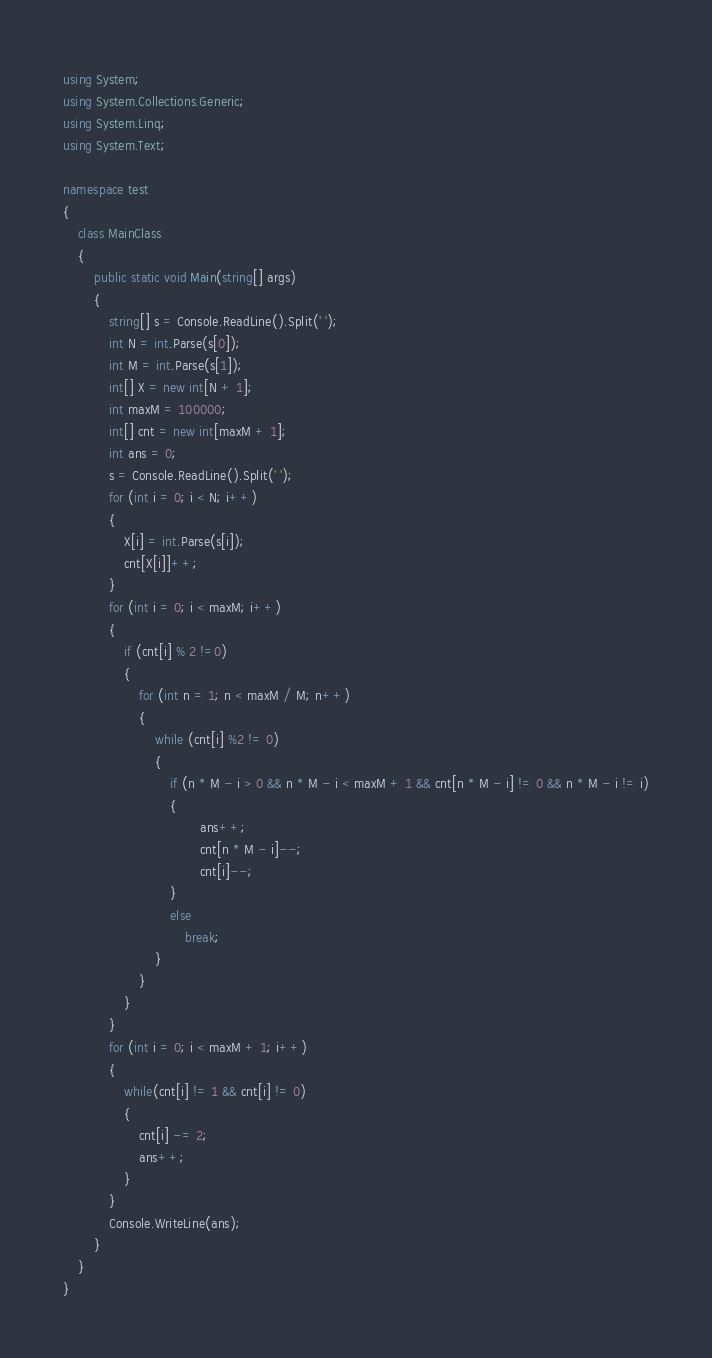Convert code to text. <code><loc_0><loc_0><loc_500><loc_500><_C#_>using System;
using System.Collections.Generic;
using System.Linq;
using System.Text;

namespace test
{
	class MainClass
	{
		public static void Main(string[] args)
		{
			string[] s = Console.ReadLine().Split(' ');
			int N = int.Parse(s[0]);
			int M = int.Parse(s[1]);
			int[] X = new int[N + 1];
			int maxM = 100000;
			int[] cnt = new int[maxM + 1];
			int ans = 0;
			s = Console.ReadLine().Split(' ');
			for (int i = 0; i < N; i++)
			{
				X[i] = int.Parse(s[i]);
				cnt[X[i]]++;
			}
			for (int i = 0; i < maxM; i++)
			{
				if (cnt[i] % 2 !=0)
				{
					for (int n = 1; n < maxM / M; n++)
					{
						while (cnt[i] %2 != 0)
						{
							if (n * M - i > 0 && n * M - i < maxM + 1 && cnt[n * M - i] != 0 && n * M - i != i)
							{
									ans++;
									cnt[n * M - i]--;
									cnt[i]--;
							}
							else
								break;
						}
					}
				}
			}
			for (int i = 0; i < maxM + 1; i++)
			{
				while(cnt[i] != 1 && cnt[i] != 0)
				{
					cnt[i] -= 2;
					ans++;
				}
			}
			Console.WriteLine(ans);
		}
	}
}
</code> 